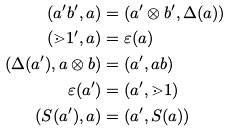Convert formula to latex. <formula><loc_0><loc_0><loc_500><loc_500>( a ^ { \prime } b ^ { \prime } , a ) & = ( a ^ { \prime } \otimes b ^ { \prime } , \Delta ( a ) ) \\ ( \mathbb { m } { 1 } ^ { \prime } , a ) & = \varepsilon ( a ) \\ ( \Delta ( a ^ { \prime } ) , a \otimes b ) & = ( a ^ { \prime } , a b ) \\ \varepsilon ( a ^ { \prime } ) & = ( a ^ { \prime } , \mathbb { m } { 1 } ) \\ ( S ( a ^ { \prime } ) , a ) & = ( a ^ { \prime } , S ( a ) )</formula> 